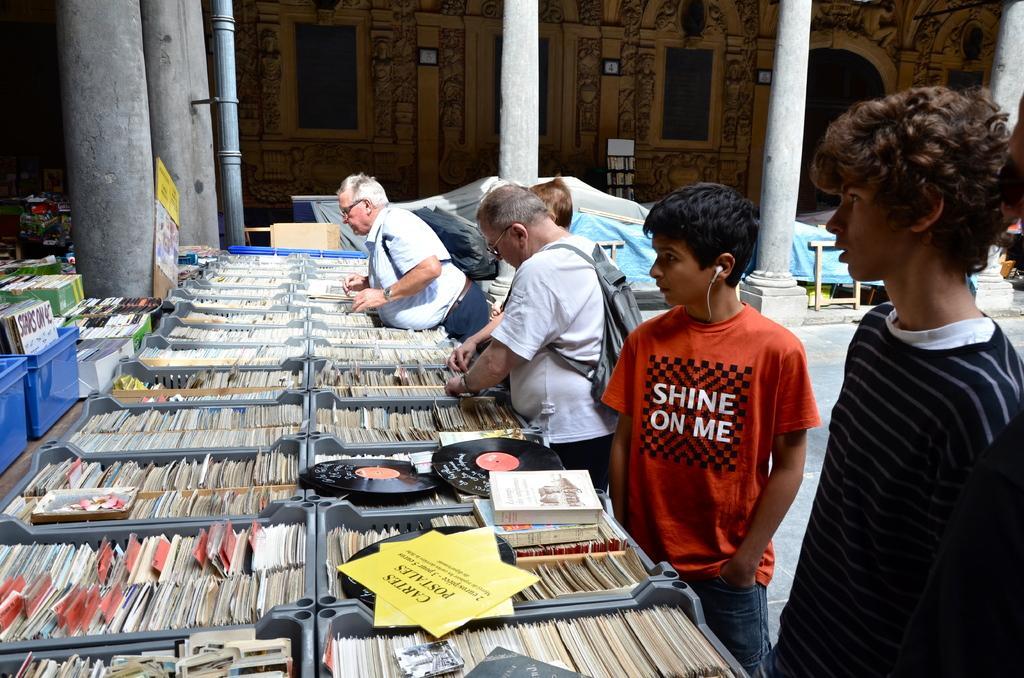How would you summarize this image in a sentence or two? In this image we can see a few people, two of them are wearing bags, there are disks in the boxes, there are cards and boards with text on them, there is a sheet, pillars, also we can see the sky. 